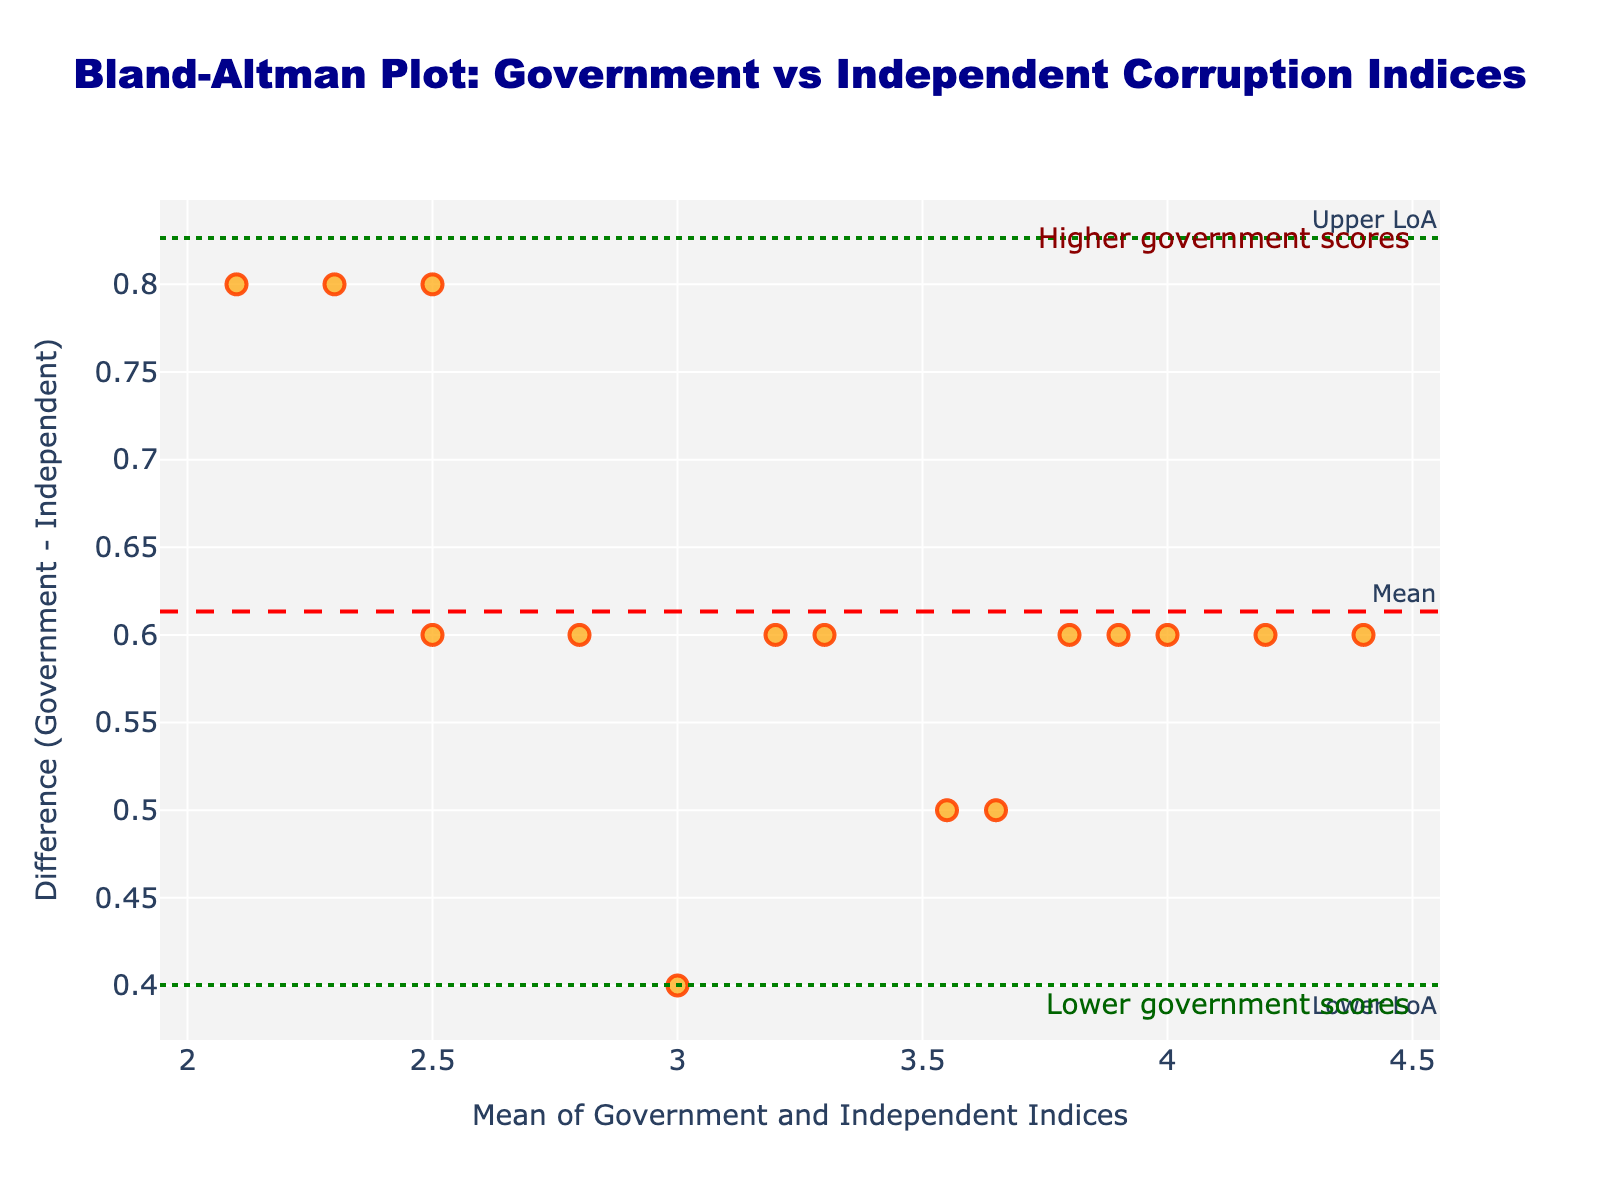What is the title of the plot? The title of the plot is shown at the top center and reads "Bland-Altman Plot: Government vs Independent Corruption Indices".
Answer: Bland-Altman Plot: Government vs Independent Corruption Indices What is the x-axis title in the plot? The x-axis title, which describes the variable represented along the horizontal axis, is "Mean of Government and Independent Indices".
Answer: Mean of Government and Independent Indices How many data points are displayed in the plot? There are 15 pairs of indices, so the plot contains 15 data points. This is determined by counting the markers present in the scatter plot.
Answer: 15 What is the color of the data points on the scatter plot? The data points are colored in an orange shade with a red outline. This visual appearance is observed directly from the scatter plot.
Answer: Orange with a red outline What does the mean difference line represent in the plot, and what is its value? The mean difference line, shown in red and dashed, represents the average difference between the government-reported and independently assessed corruption indices. The exact value can be found where the line intersects the y-axis at approximately 0.6.
Answer: The average difference, approximately 0.6 What are the upper and lower limits of agreement in the plot? The upper and lower limits of agreement are marked by green dotted lines. The upper limit is roughly around 1.3, and the lower limit is about -0.1. These values can be read off where the lines intersect the y-axis.
Answer: Upper limit ~1.3, Lower limit ~-0.1 What can you infer if a data point lies above the upper limit of agreement? If a data point lies above the upper limit of agreement, it means that the government-reported index is significantly higher than the independent assessment for that instance, indicating a large disagreement.
Answer: Significant disagreement with higher government-reported scores Where are data points positioned if the government-reported index always exceeds the independent index? Data points would be positioned above the zero line (difference = 0), with positive differences indicating higher government-reported indexes than independent assessments.
Answer: Above the zero line Based on the plot, do we see more cases of higher government scores or lower government scores? The majority of the data points are above the zero difference line, indicating more instances where the government-reported scores are higher than the independent assessments.
Answer: Higher government scores Is there any visual indication on the plot that evaluates the biases in reporting between the government and independent assessments? The plot uses the mean difference line and limits of agreement to evaluate biases. The presence of more points above the mean difference line suggests a bias where government scores tend to be higher than independent assessments.
Answer: Bias towards higher government scores 